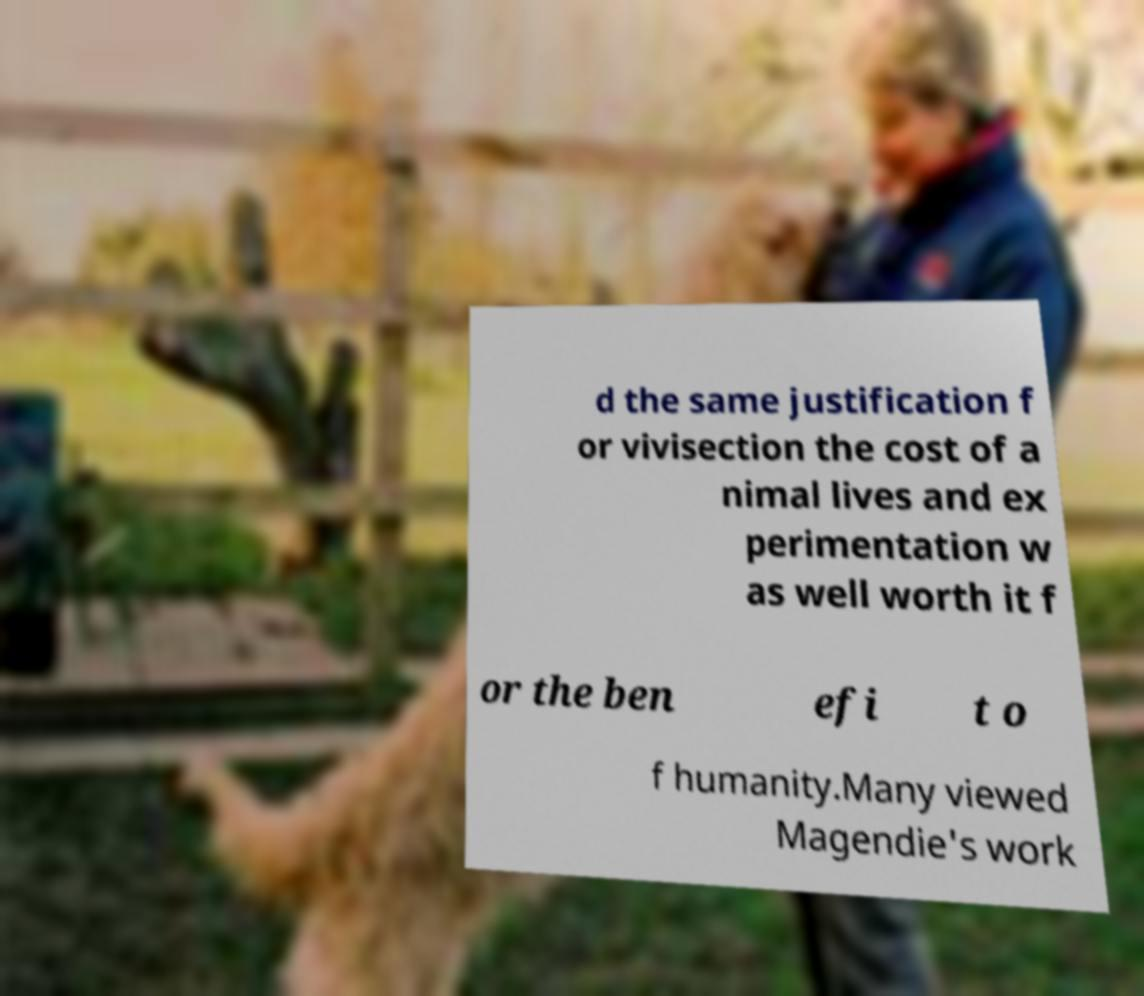Can you read and provide the text displayed in the image?This photo seems to have some interesting text. Can you extract and type it out for me? d the same justification f or vivisection the cost of a nimal lives and ex perimentation w as well worth it f or the ben efi t o f humanity.Many viewed Magendie's work 